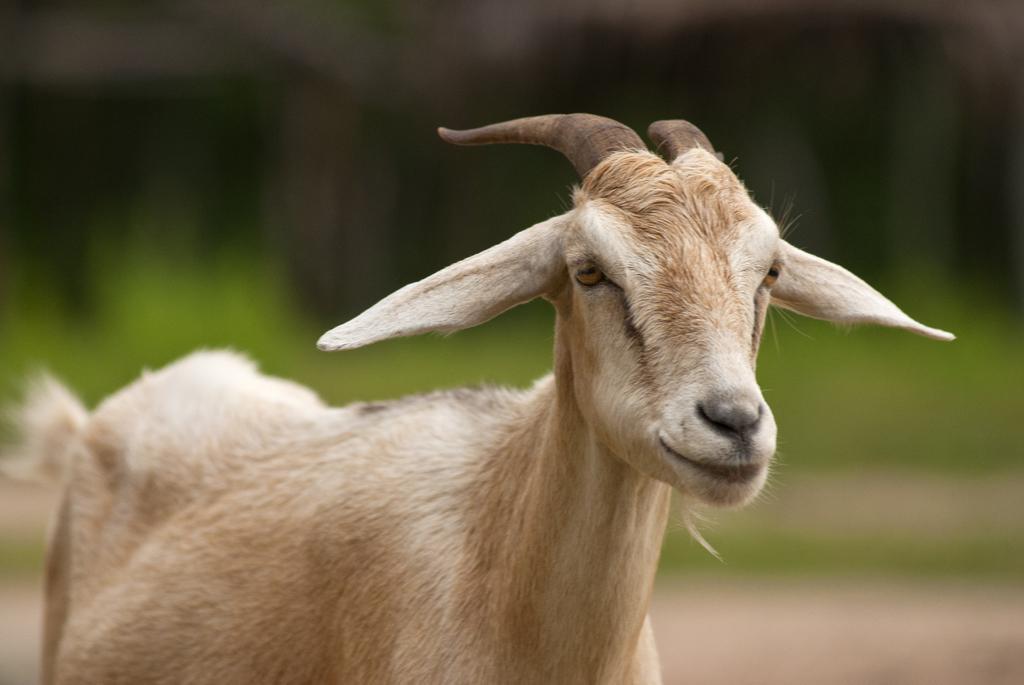Please provide a concise description of this image. In this image I can see a cream and white colour goat in the front. In the background I can see green colour and I can see this image is blurry in the background. 